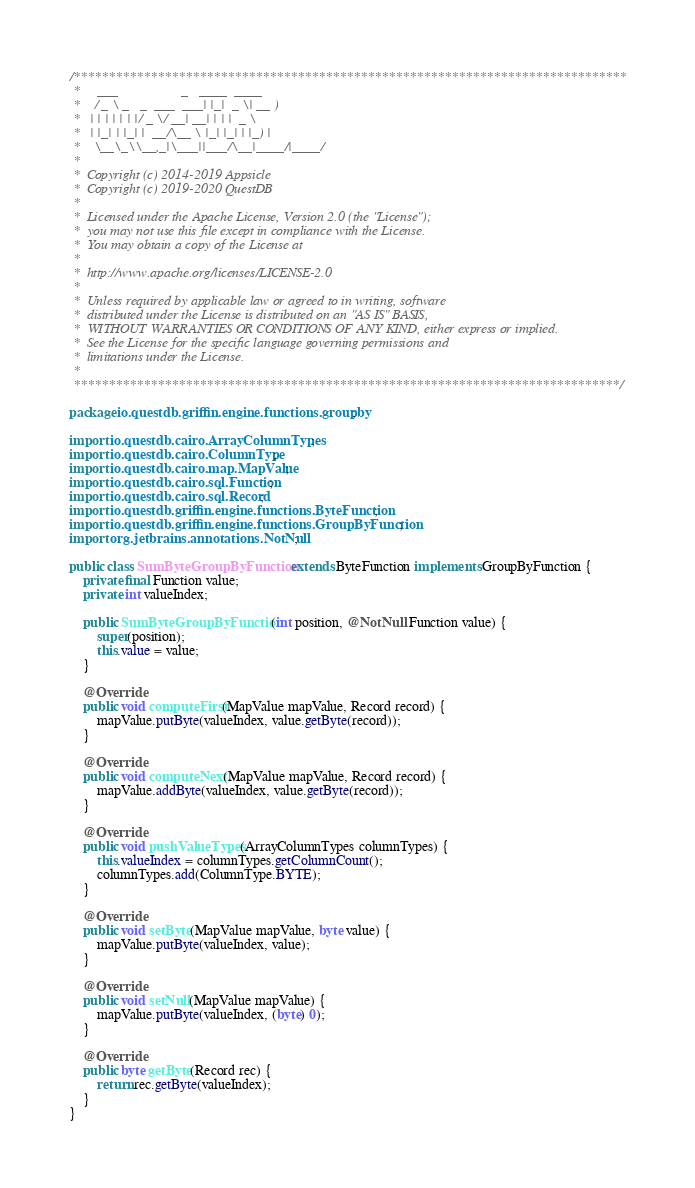<code> <loc_0><loc_0><loc_500><loc_500><_Java_>/*******************************************************************************
 *     ___                  _   ____  ____
 *    / _ \ _   _  ___  ___| |_|  _ \| __ )
 *   | | | | | | |/ _ \/ __| __| | | |  _ \
 *   | |_| | |_| |  __/\__ \ |_| |_| | |_) |
 *    \__\_\\__,_|\___||___/\__|____/|____/
 *
 *  Copyright (c) 2014-2019 Appsicle
 *  Copyright (c) 2019-2020 QuestDB
 *
 *  Licensed under the Apache License, Version 2.0 (the "License");
 *  you may not use this file except in compliance with the License.
 *  You may obtain a copy of the License at
 *
 *  http://www.apache.org/licenses/LICENSE-2.0
 *
 *  Unless required by applicable law or agreed to in writing, software
 *  distributed under the License is distributed on an "AS IS" BASIS,
 *  WITHOUT WARRANTIES OR CONDITIONS OF ANY KIND, either express or implied.
 *  See the License for the specific language governing permissions and
 *  limitations under the License.
 *
 ******************************************************************************/

package io.questdb.griffin.engine.functions.groupby;

import io.questdb.cairo.ArrayColumnTypes;
import io.questdb.cairo.ColumnType;
import io.questdb.cairo.map.MapValue;
import io.questdb.cairo.sql.Function;
import io.questdb.cairo.sql.Record;
import io.questdb.griffin.engine.functions.ByteFunction;
import io.questdb.griffin.engine.functions.GroupByFunction;
import org.jetbrains.annotations.NotNull;

public class SumByteGroupByFunction extends ByteFunction implements GroupByFunction {
    private final Function value;
    private int valueIndex;

    public SumByteGroupByFunction(int position, @NotNull Function value) {
        super(position);
        this.value = value;
    }

    @Override
    public void computeFirst(MapValue mapValue, Record record) {
        mapValue.putByte(valueIndex, value.getByte(record));
    }

    @Override
    public void computeNext(MapValue mapValue, Record record) {
        mapValue.addByte(valueIndex, value.getByte(record));
    }

    @Override
    public void pushValueTypes(ArrayColumnTypes columnTypes) {
        this.valueIndex = columnTypes.getColumnCount();
        columnTypes.add(ColumnType.BYTE);
    }

    @Override
    public void setByte(MapValue mapValue, byte value) {
        mapValue.putByte(valueIndex, value);
    }

    @Override
    public void setNull(MapValue mapValue) {
        mapValue.putByte(valueIndex, (byte) 0);
    }

    @Override
    public byte getByte(Record rec) {
        return rec.getByte(valueIndex);
    }
}
</code> 